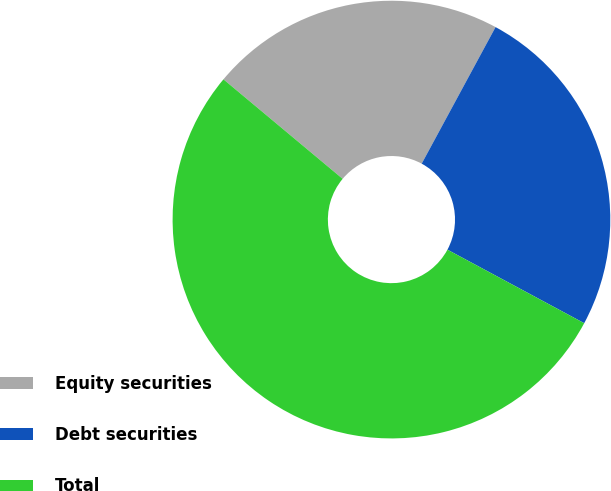<chart> <loc_0><loc_0><loc_500><loc_500><pie_chart><fcel>Equity securities<fcel>Debt securities<fcel>Total<nl><fcel>21.82%<fcel>24.96%<fcel>53.22%<nl></chart> 